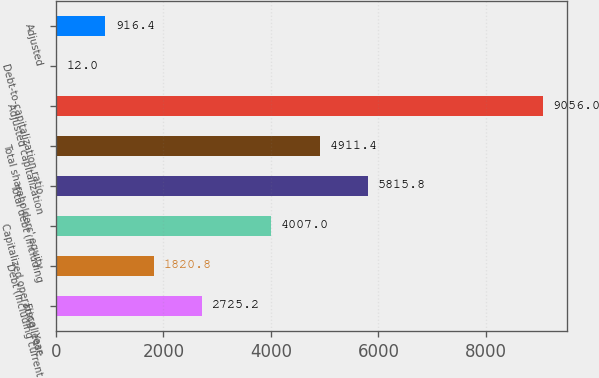Convert chart. <chart><loc_0><loc_0><loc_500><loc_500><bar_chart><fcel>Fiscal Year<fcel>Debt (including current<fcel>Capitalized operating lease<fcel>Total debt (including<fcel>Total shareholders' equity<fcel>Adjusted capitalization<fcel>Debt-to-capitalization ratio<fcel>Adjusted<nl><fcel>2725.2<fcel>1820.8<fcel>4007<fcel>5815.8<fcel>4911.4<fcel>9056<fcel>12<fcel>916.4<nl></chart> 